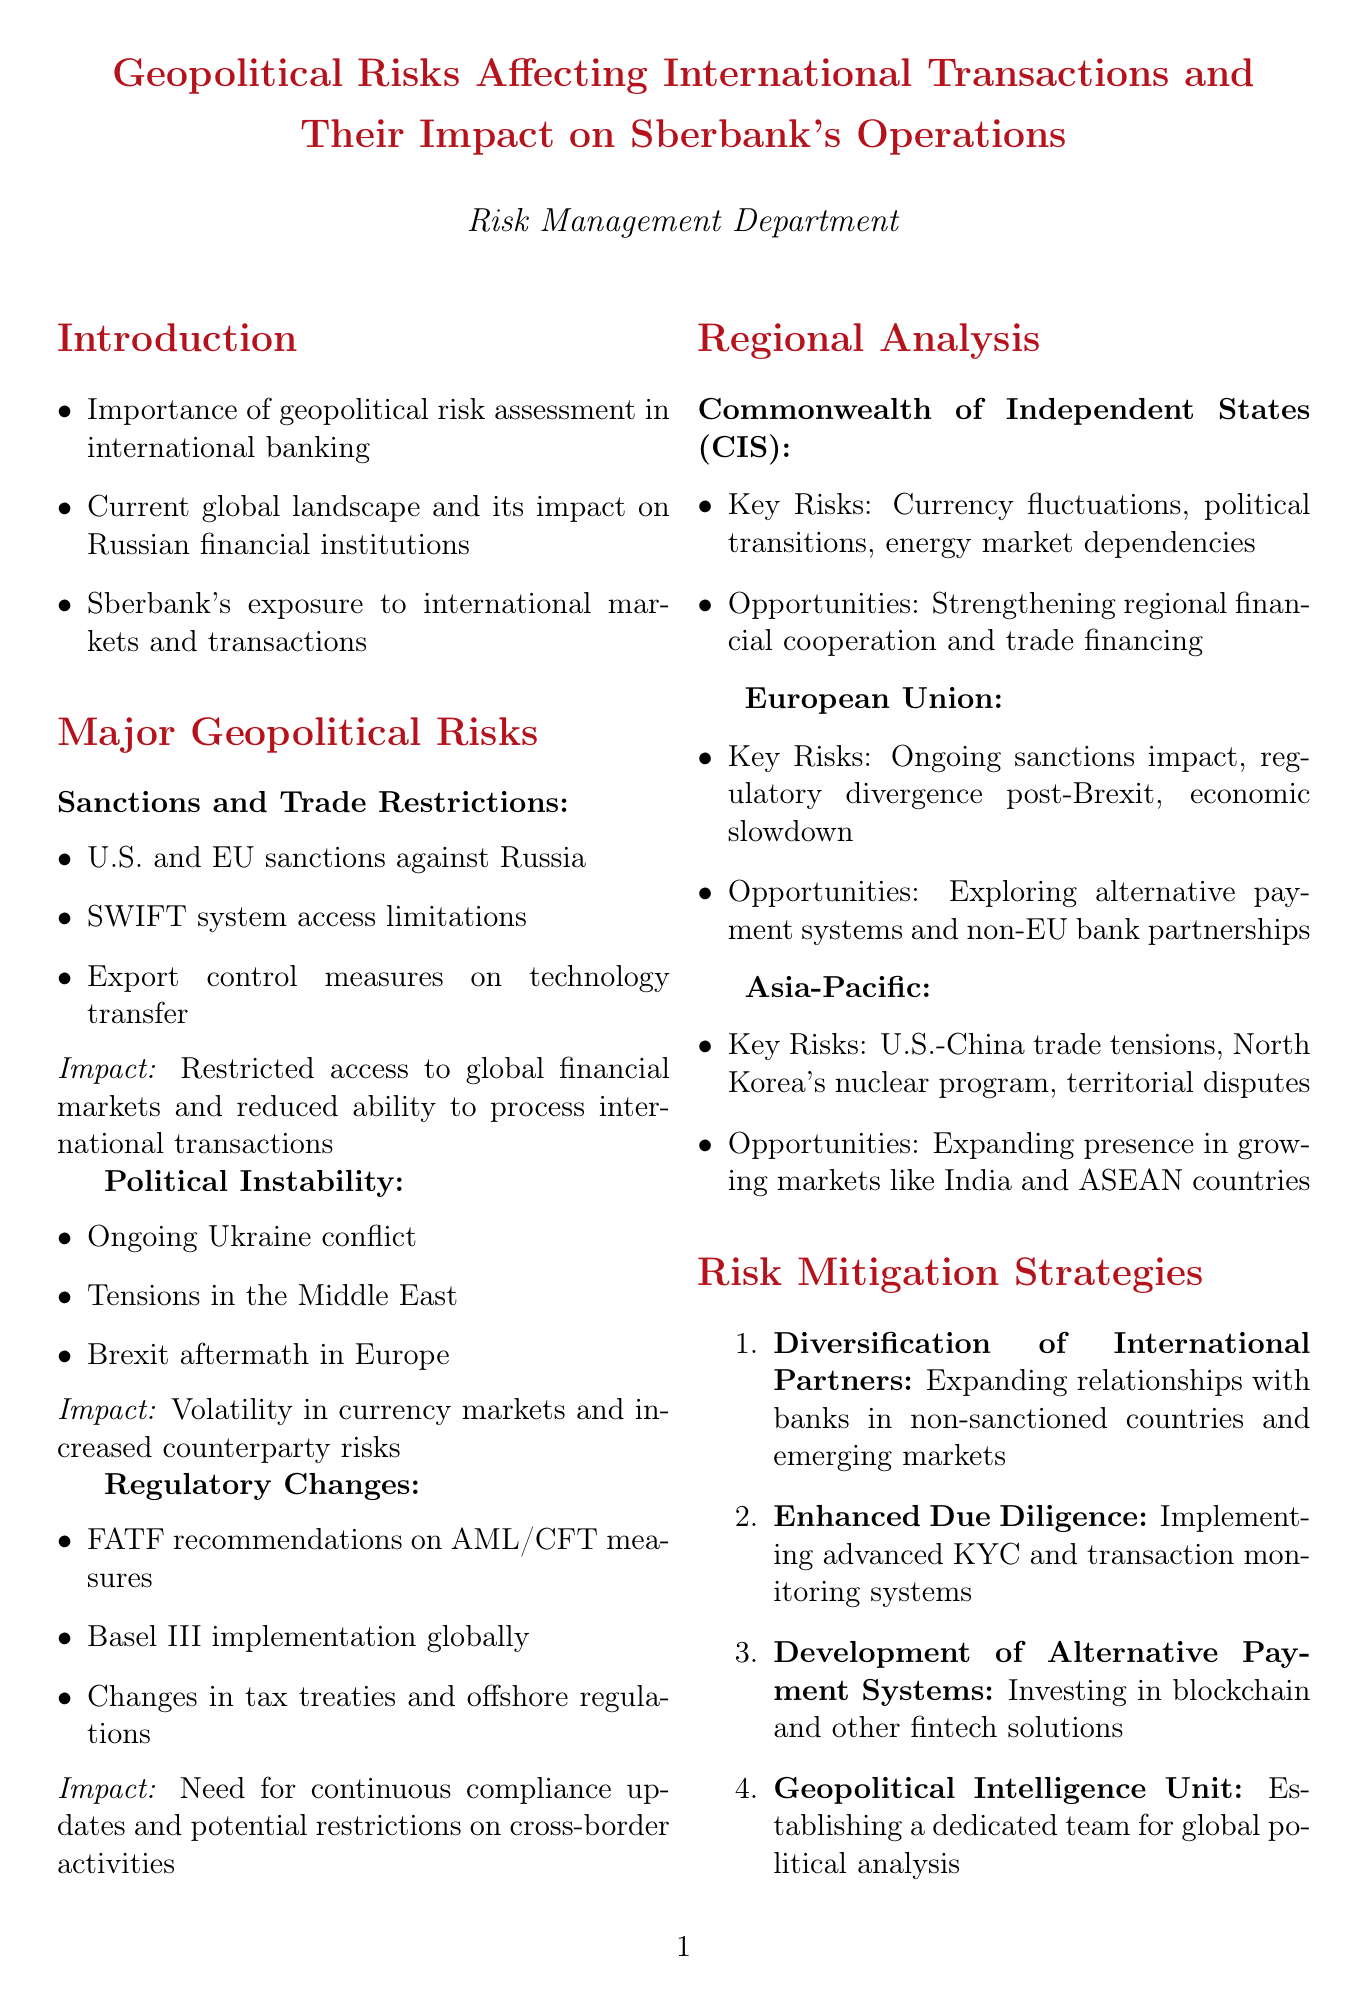What is the title of the memo? The title of the memo is clearly stated at the beginning of the document.
Answer: Geopolitical Risks Affecting International Transactions and Their Impact on Sberbank's Operations What are the three major categories of geopolitical risks mentioned? The document lists the major geopolitical risks in a structured manner with distinct categories.
Answer: Sanctions and Trade Restrictions, Political Instability, Regulatory Changes What is one example of a risk under Political Instability? The document provides specific examples under each risk category for clarity.
Answer: Ongoing Ukraine conflict What recommendations are made in the conclusion? The conclusion summarizes the main recommendations as bullet points.
Answer: Regular review and update of the bank's geopolitical risk assessment framework What region has key risks related to currency fluctuations? The document mentions key risks specific to different regions, including currency fluctuations.
Answer: Commonwealth of Independent States (CIS) What is one of the opportunities mentioned for the European Union region? The document highlights opportunities available in different regions.
Answer: Exploring alternative payment systems and partnerships with non-EU banks What strategy involves investing in blockchain and fintech solutions? The document lists various risk mitigation strategies with corresponding descriptions.
Answer: Development of Alternative Payment Systems How many regional analyses are presented in the memo? The document categorizes the geopolitical risks by regions, offering analysis for each.
Answer: Three 